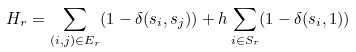Convert formula to latex. <formula><loc_0><loc_0><loc_500><loc_500>H _ { r } = \sum _ { ( i , j ) \in E _ { r } } ( 1 - \delta ( s _ { i } , s _ { j } ) ) + h \sum _ { i \in S _ { r } } ( 1 - \delta ( s _ { i } , 1 ) )</formula> 